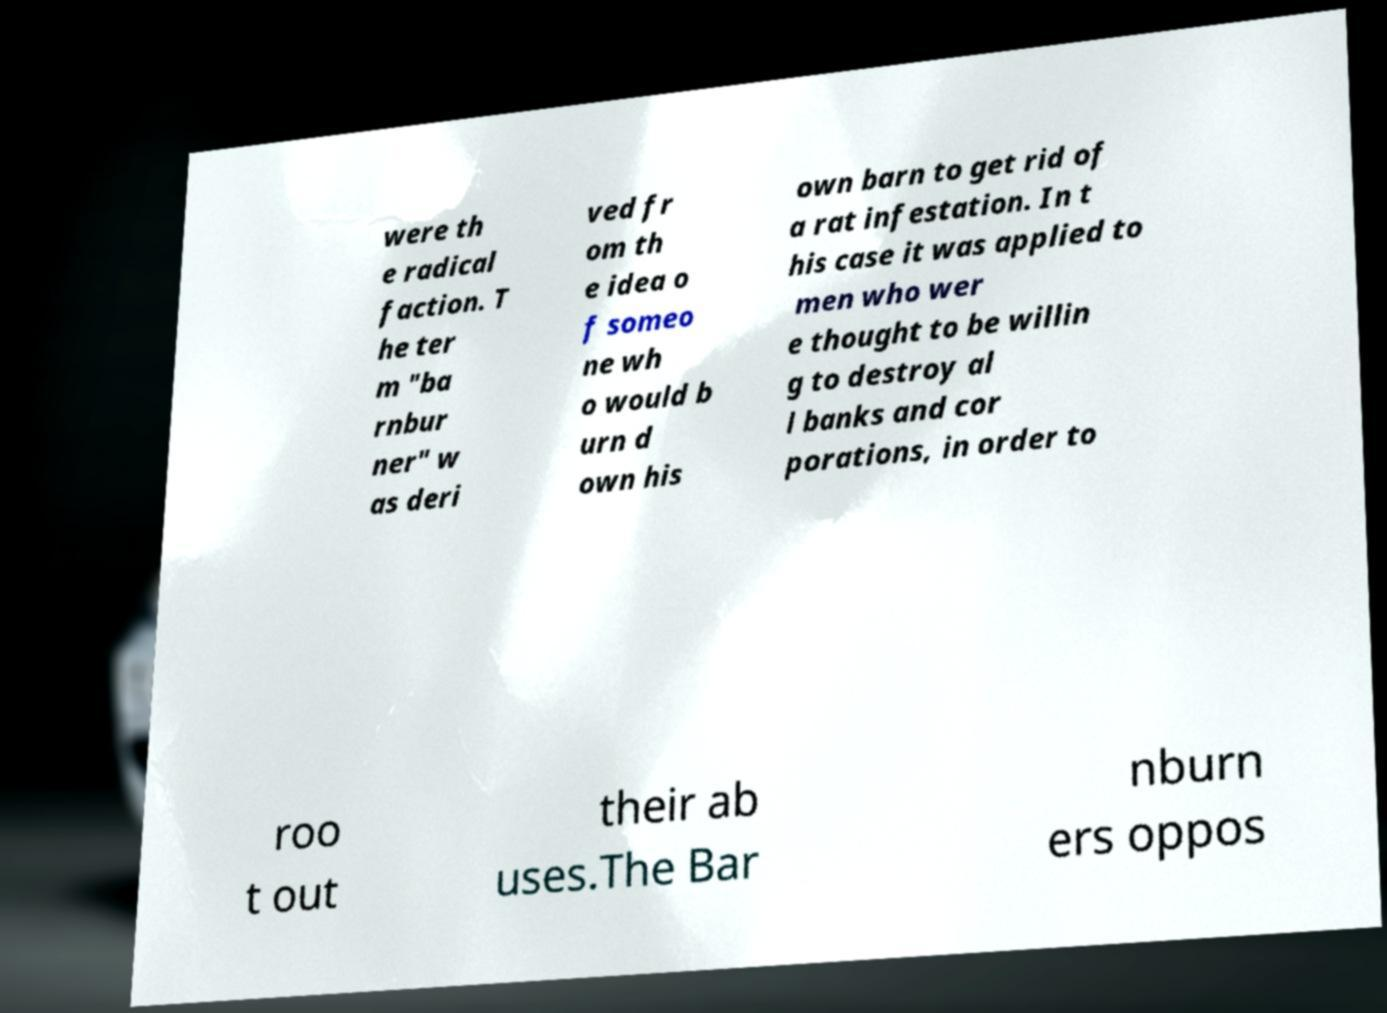For documentation purposes, I need the text within this image transcribed. Could you provide that? were th e radical faction. T he ter m "ba rnbur ner" w as deri ved fr om th e idea o f someo ne wh o would b urn d own his own barn to get rid of a rat infestation. In t his case it was applied to men who wer e thought to be willin g to destroy al l banks and cor porations, in order to roo t out their ab uses.The Bar nburn ers oppos 